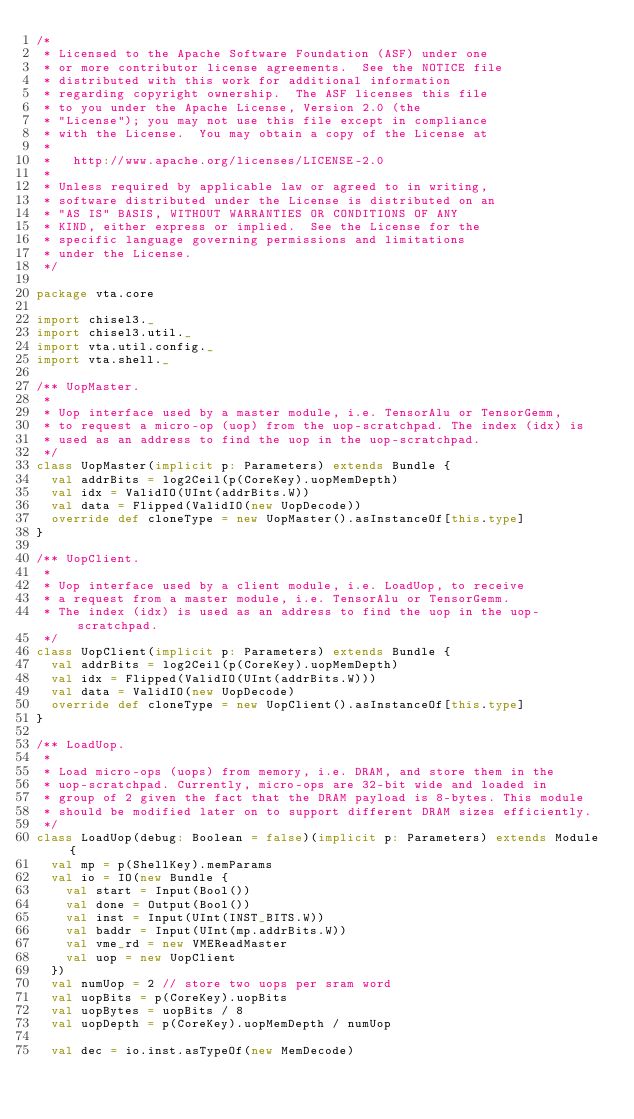Convert code to text. <code><loc_0><loc_0><loc_500><loc_500><_Scala_>/*
 * Licensed to the Apache Software Foundation (ASF) under one
 * or more contributor license agreements.  See the NOTICE file
 * distributed with this work for additional information
 * regarding copyright ownership.  The ASF licenses this file
 * to you under the Apache License, Version 2.0 (the
 * "License"); you may not use this file except in compliance
 * with the License.  You may obtain a copy of the License at
 *
 *   http://www.apache.org/licenses/LICENSE-2.0
 *
 * Unless required by applicable law or agreed to in writing,
 * software distributed under the License is distributed on an
 * "AS IS" BASIS, WITHOUT WARRANTIES OR CONDITIONS OF ANY
 * KIND, either express or implied.  See the License for the
 * specific language governing permissions and limitations
 * under the License.
 */

package vta.core

import chisel3._
import chisel3.util._
import vta.util.config._
import vta.shell._

/** UopMaster.
 *
 * Uop interface used by a master module, i.e. TensorAlu or TensorGemm,
 * to request a micro-op (uop) from the uop-scratchpad. The index (idx) is
 * used as an address to find the uop in the uop-scratchpad.
 */
class UopMaster(implicit p: Parameters) extends Bundle {
  val addrBits = log2Ceil(p(CoreKey).uopMemDepth)
  val idx = ValidIO(UInt(addrBits.W))
  val data = Flipped(ValidIO(new UopDecode))
  override def cloneType = new UopMaster().asInstanceOf[this.type]
}

/** UopClient.
 *
 * Uop interface used by a client module, i.e. LoadUop, to receive
 * a request from a master module, i.e. TensorAlu or TensorGemm.
 * The index (idx) is used as an address to find the uop in the uop-scratchpad.
 */
class UopClient(implicit p: Parameters) extends Bundle {
  val addrBits = log2Ceil(p(CoreKey).uopMemDepth)
  val idx = Flipped(ValidIO(UInt(addrBits.W)))
  val data = ValidIO(new UopDecode)
  override def cloneType = new UopClient().asInstanceOf[this.type]
}

/** LoadUop.
 *
 * Load micro-ops (uops) from memory, i.e. DRAM, and store them in the
 * uop-scratchpad. Currently, micro-ops are 32-bit wide and loaded in
 * group of 2 given the fact that the DRAM payload is 8-bytes. This module
 * should be modified later on to support different DRAM sizes efficiently.
 */
class LoadUop(debug: Boolean = false)(implicit p: Parameters) extends Module {
  val mp = p(ShellKey).memParams
  val io = IO(new Bundle {
    val start = Input(Bool())
    val done = Output(Bool())
    val inst = Input(UInt(INST_BITS.W))
    val baddr = Input(UInt(mp.addrBits.W))
    val vme_rd = new VMEReadMaster
    val uop = new UopClient
  })
  val numUop = 2 // store two uops per sram word
  val uopBits = p(CoreKey).uopBits
  val uopBytes = uopBits / 8
  val uopDepth = p(CoreKey).uopMemDepth / numUop

  val dec = io.inst.asTypeOf(new MemDecode)</code> 